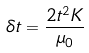<formula> <loc_0><loc_0><loc_500><loc_500>\delta t = \frac { 2 t ^ { 2 } K } { \mu _ { 0 } }</formula> 